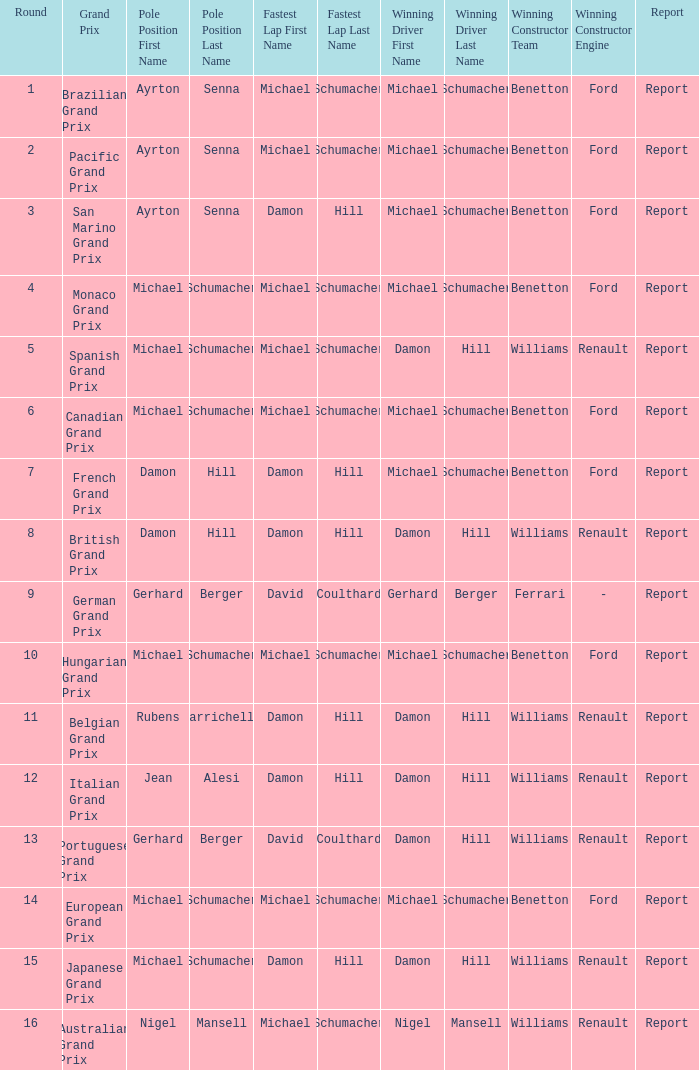Name the fastest lap for the brazilian grand prix Michael Schumacher. 